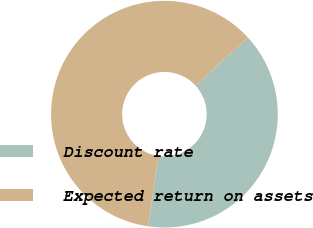Convert chart to OTSL. <chart><loc_0><loc_0><loc_500><loc_500><pie_chart><fcel>Discount rate<fcel>Expected return on assets<nl><fcel>39.12%<fcel>60.88%<nl></chart> 